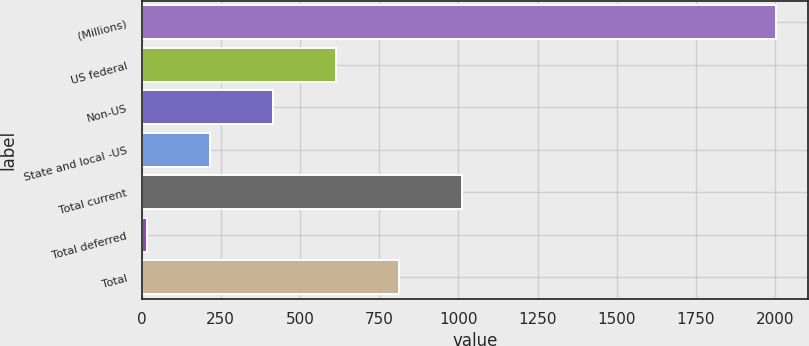Convert chart to OTSL. <chart><loc_0><loc_0><loc_500><loc_500><bar_chart><fcel>(Millions)<fcel>US federal<fcel>Non-US<fcel>State and local -US<fcel>Total current<fcel>Total deferred<fcel>Total<nl><fcel>2003<fcel>613.5<fcel>415<fcel>216.5<fcel>1010.5<fcel>18<fcel>812<nl></chart> 